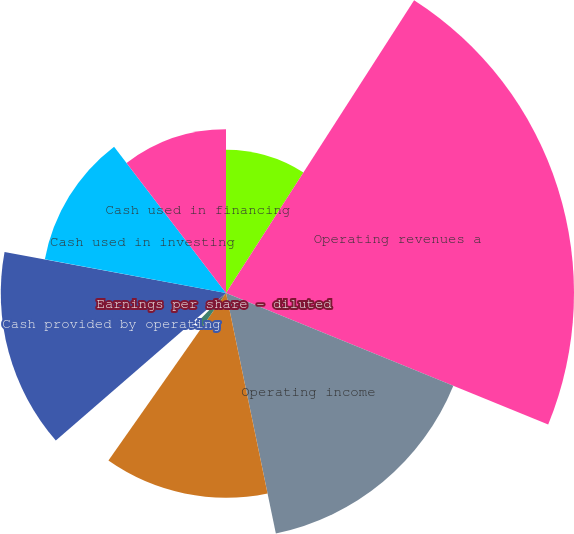<chart> <loc_0><loc_0><loc_500><loc_500><pie_chart><fcel>Millions Except per Share<fcel>Operating revenues a<fcel>Operating income<fcel>Net income<fcel>Earnings per share - basic<fcel>Earnings per share - diluted<fcel>Dividends declared per share<fcel>Cash provided by operating<fcel>Cash used in investing<fcel>Cash used in financing<nl><fcel>9.09%<fcel>22.08%<fcel>15.58%<fcel>12.99%<fcel>2.6%<fcel>1.3%<fcel>0.0%<fcel>14.29%<fcel>11.69%<fcel>10.39%<nl></chart> 